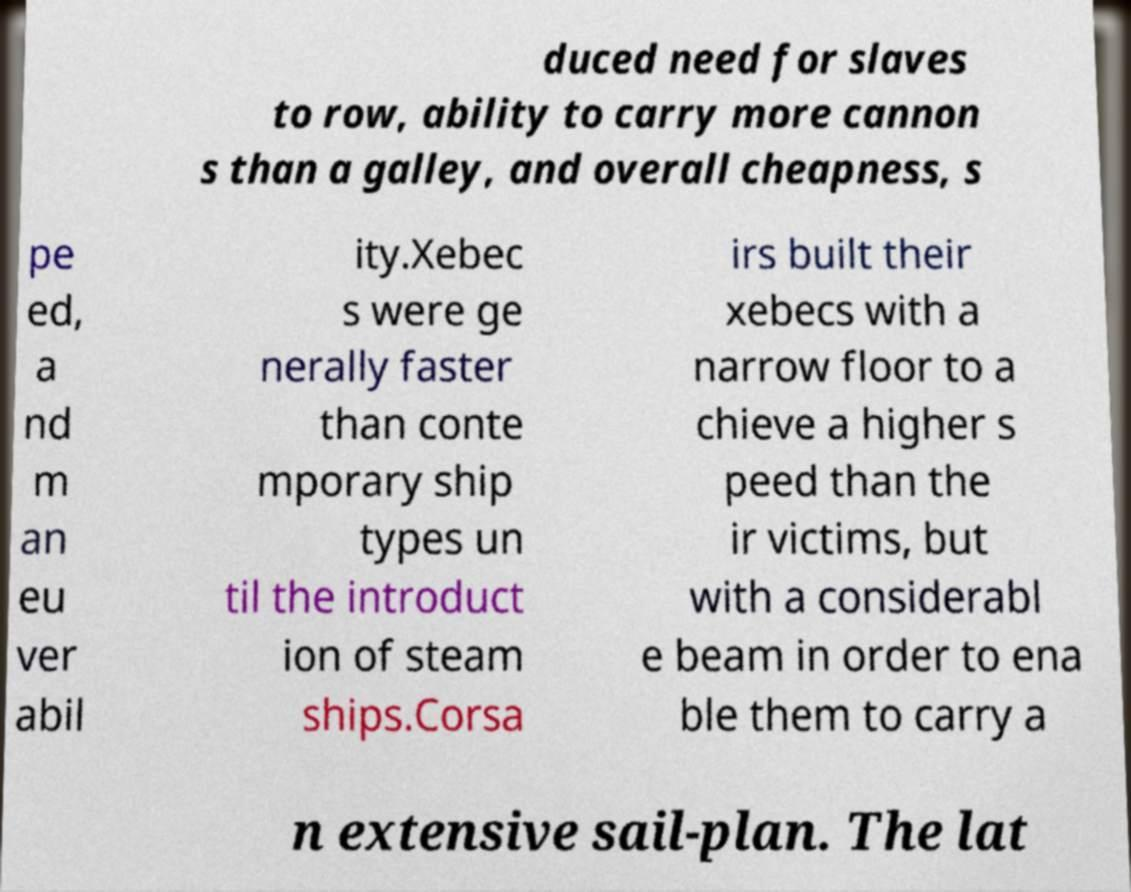There's text embedded in this image that I need extracted. Can you transcribe it verbatim? duced need for slaves to row, ability to carry more cannon s than a galley, and overall cheapness, s pe ed, a nd m an eu ver abil ity.Xebec s were ge nerally faster than conte mporary ship types un til the introduct ion of steam ships.Corsa irs built their xebecs with a narrow floor to a chieve a higher s peed than the ir victims, but with a considerabl e beam in order to ena ble them to carry a n extensive sail-plan. The lat 